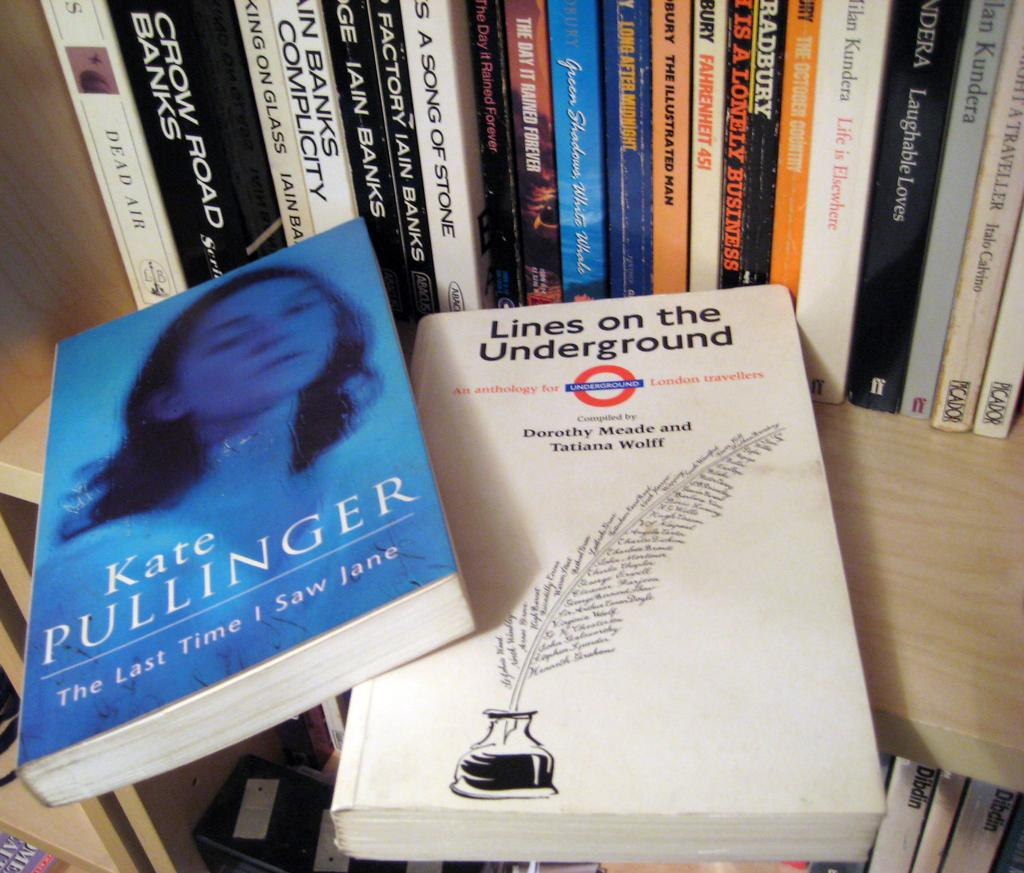<image>
Give a short and clear explanation of the subsequent image. A shelf full of books with a book that is titles Lines on the Underground sitting up front. 